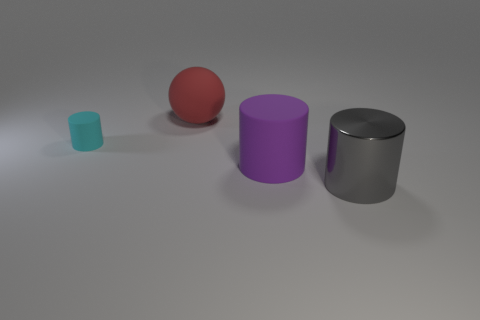Add 4 large blue balls. How many objects exist? 8 Subtract all cylinders. How many objects are left? 1 Subtract 1 gray cylinders. How many objects are left? 3 Subtract all tiny cyan matte cylinders. Subtract all metallic cylinders. How many objects are left? 2 Add 3 big purple matte things. How many big purple matte things are left? 4 Add 4 yellow spheres. How many yellow spheres exist? 4 